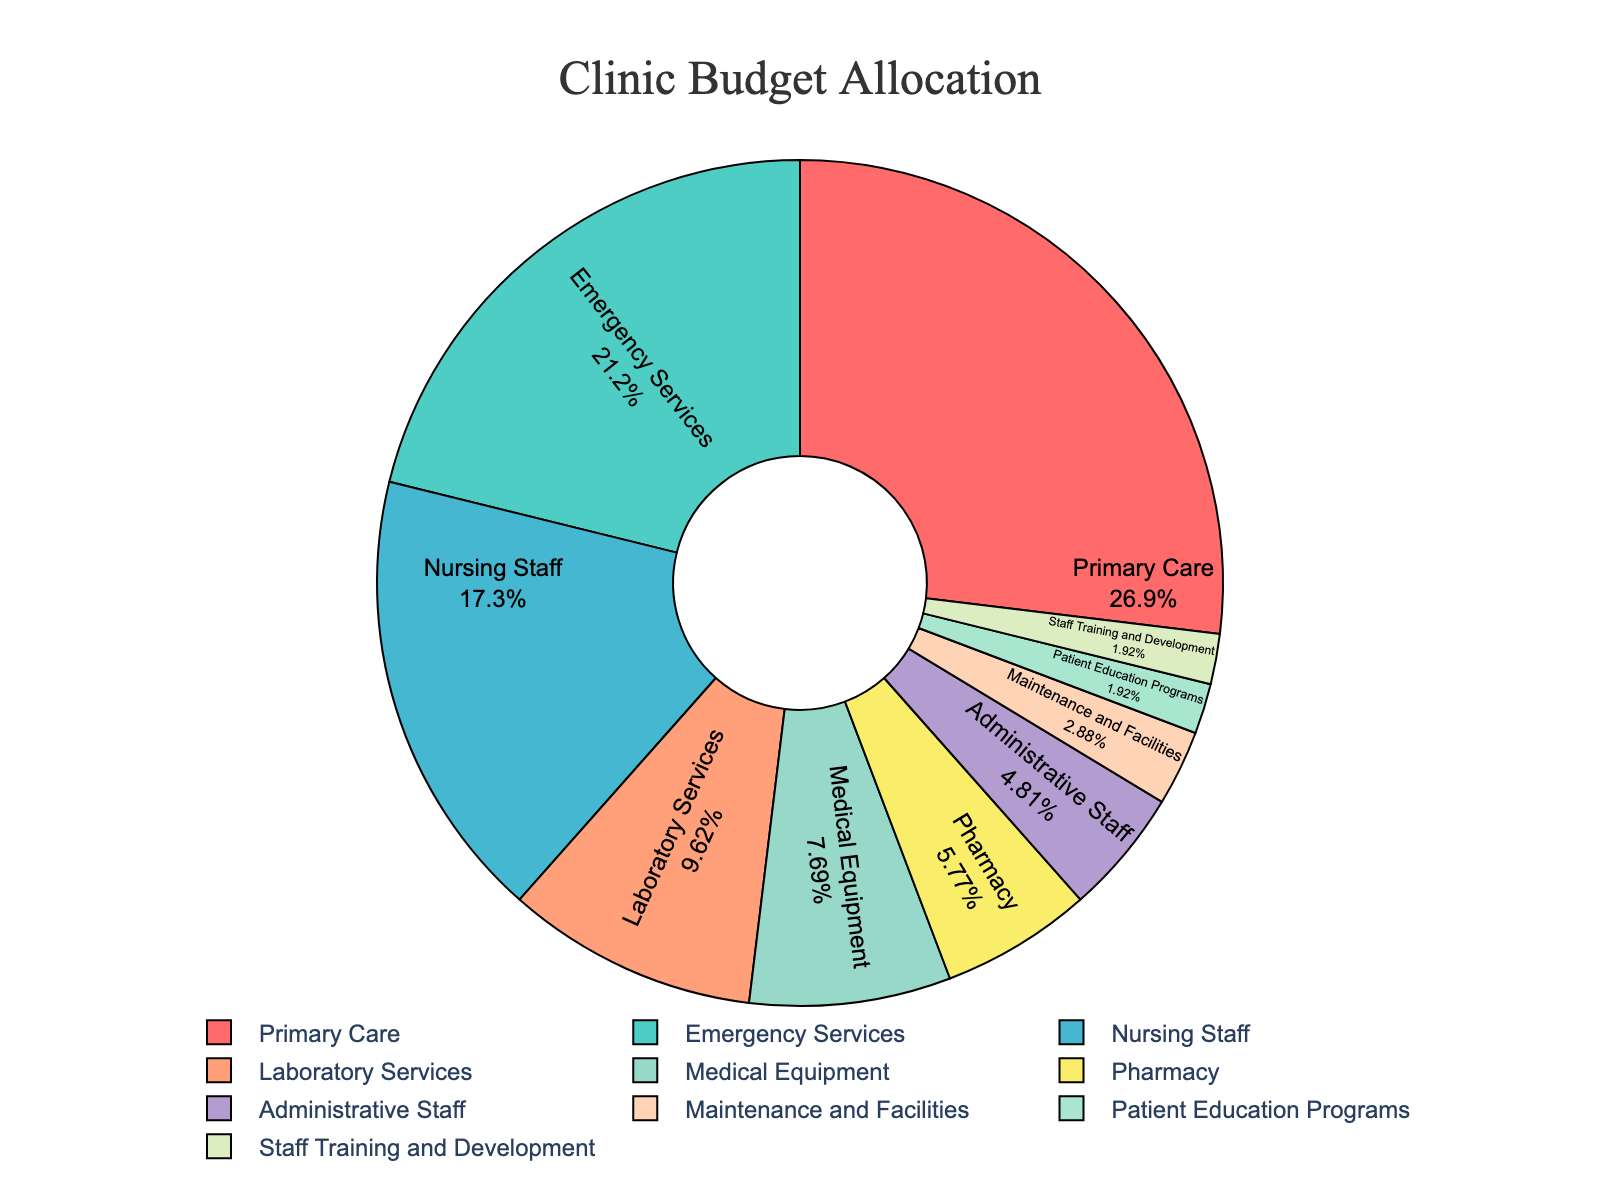Which department/service received the largest share of the budget? The largest segment in the pie chart is labeled "Primary Care" with 28% of the budget.
Answer: Primary Care Which department received more budget allocation: Emergency Services or Nursing Staff? Comparing the two segments, Emergency Services received 22% while Nursing Staff received 18%.
Answer: Emergency Services What fraction of the budget is allocated to Administrative Staff and Maintenance and Facilities combined? Administrative Staff received 5% and Maintenance and Facilities received 3%. Their combined allocation is 5% + 3% = 8%.
Answer: 8% Is the budget allocated to Pharmacy greater than or less than Medical Equipment? Comparing the segments, Pharmacy received 6%, while Medical Equipment received a higher portion at 8%.
Answer: Less than What is the combined budget allocation for Patient Education Programs and Staff Training and Development? Both Patient Education Programs and Staff Training and Development received 2% each. So, 2% + 2% = 4%.
Answer: 4% Which part of the chart represents the Nursing Staff and what is the budget allocation for it? The Nursing Staff is represented by the third largest segment in the pie chart with 18% of the total budget.
Answer: 18% How much more budget is allocated to Laboratory Services compared to Pharmacy? Laboratory Services received 10%, and Pharmacy received 6%. The difference is 10% - 6% = 4%.
Answer: 4% Which department/service has the smallest budget allocation, and what percentage of the budget does this department/service receive? Patient Education Programs and Staff Training and Development both received the smallest budget allocation of 2%.
Answer: Patient Education Programs, Staff Training and Development, 2% What is the visual color representing the Maintenance and Facilities? Looking at the pie chart, Maintenance and Facilities is represented by a segment colored in a light green shade.
Answer: Light green Is the budget allocation to Medical Equipment higher or lower than the average budget allocation across all departments/services? First, calculate the average budget allocation: (28+22+18+10+8+6+5+3+2+2)/10 = 10.4%. Medical Equipment received 8%, which is lower than the average allocation of 10.4%.
Answer: Lower 